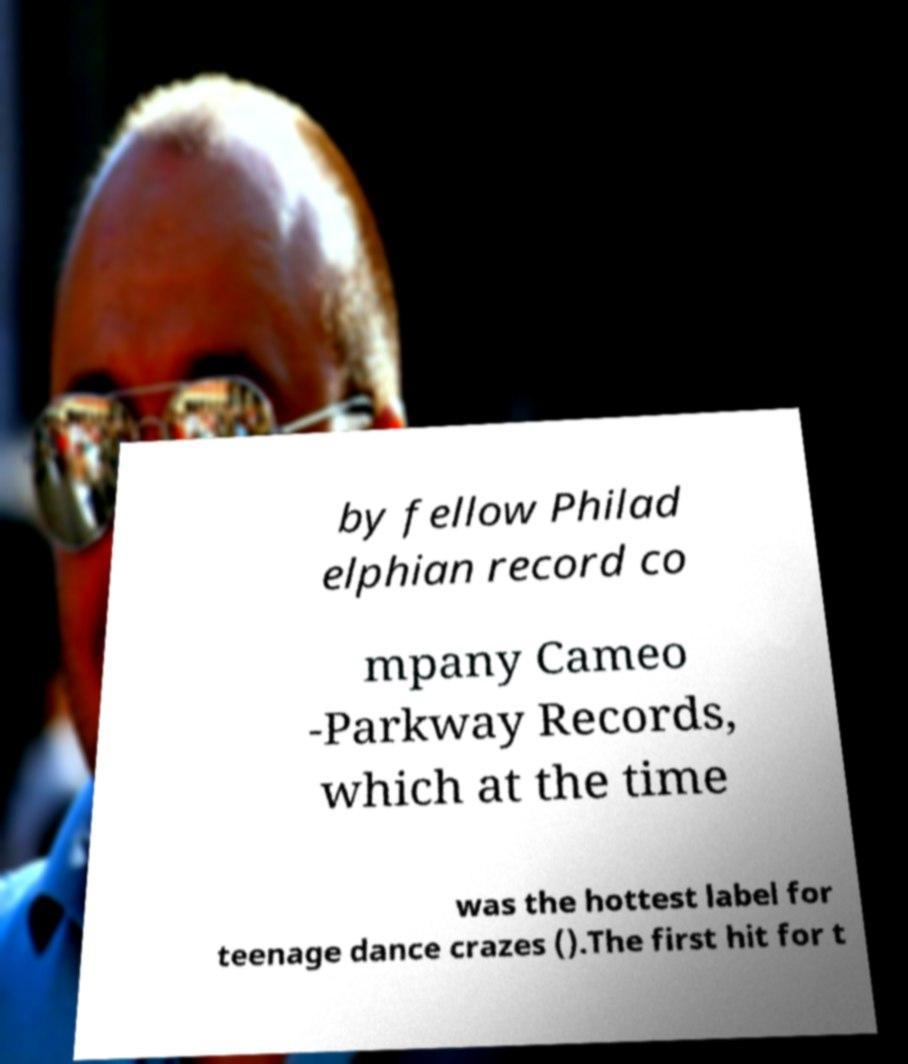Could you extract and type out the text from this image? by fellow Philad elphian record co mpany Cameo -Parkway Records, which at the time was the hottest label for teenage dance crazes ().The first hit for t 